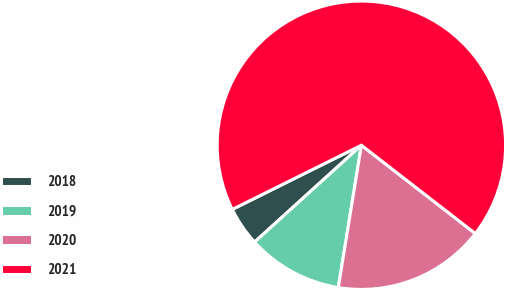Convert chart to OTSL. <chart><loc_0><loc_0><loc_500><loc_500><pie_chart><fcel>2018<fcel>2019<fcel>2020<fcel>2021<nl><fcel>4.38%<fcel>10.72%<fcel>17.07%<fcel>67.83%<nl></chart> 